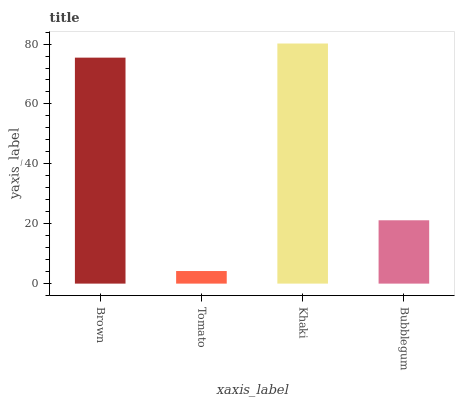Is Khaki the minimum?
Answer yes or no. No. Is Tomato the maximum?
Answer yes or no. No. Is Khaki greater than Tomato?
Answer yes or no. Yes. Is Tomato less than Khaki?
Answer yes or no. Yes. Is Tomato greater than Khaki?
Answer yes or no. No. Is Khaki less than Tomato?
Answer yes or no. No. Is Brown the high median?
Answer yes or no. Yes. Is Bubblegum the low median?
Answer yes or no. Yes. Is Khaki the high median?
Answer yes or no. No. Is Brown the low median?
Answer yes or no. No. 